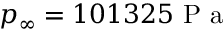<formula> <loc_0><loc_0><loc_500><loc_500>p _ { \infty } = 1 0 1 3 2 5 P a</formula> 